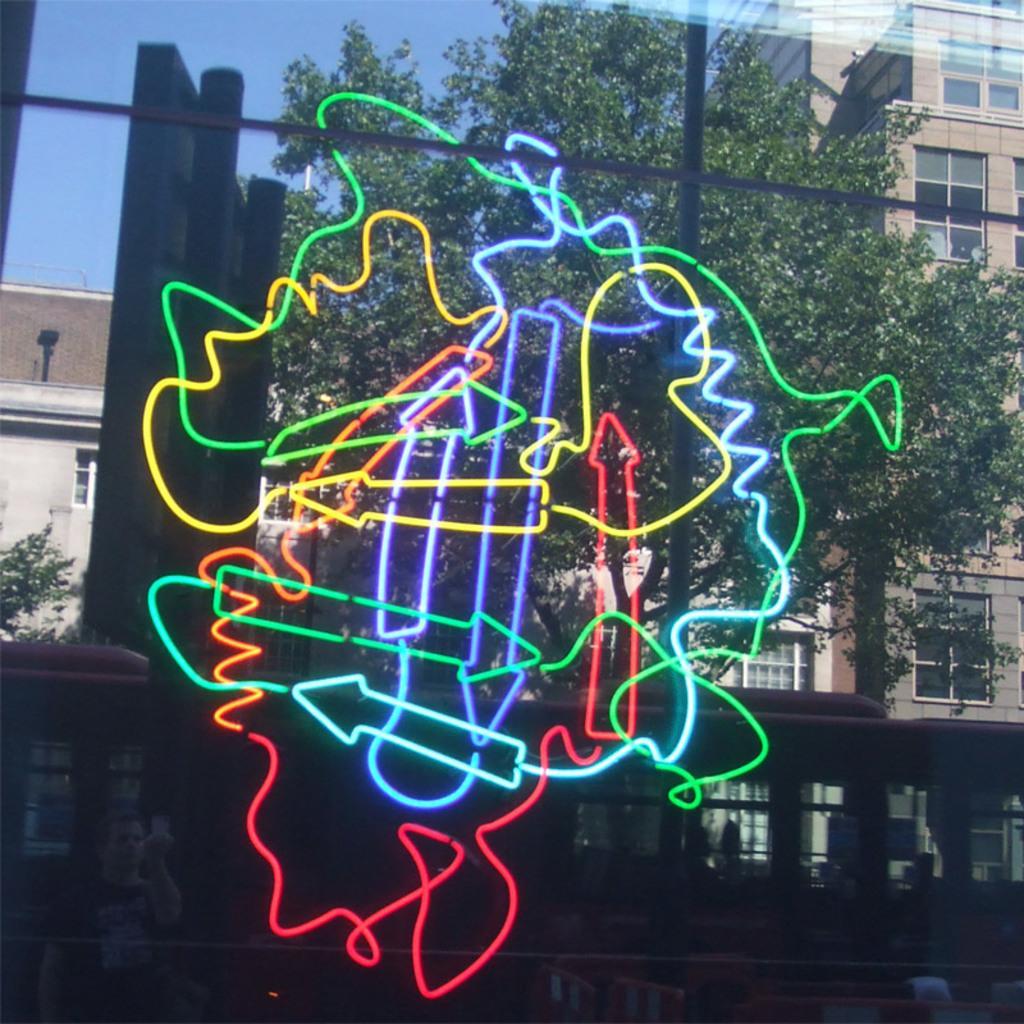In one or two sentences, can you explain what this image depicts? There is an object which is in different colors and there is a vehicle,tree and buildings in the background. 